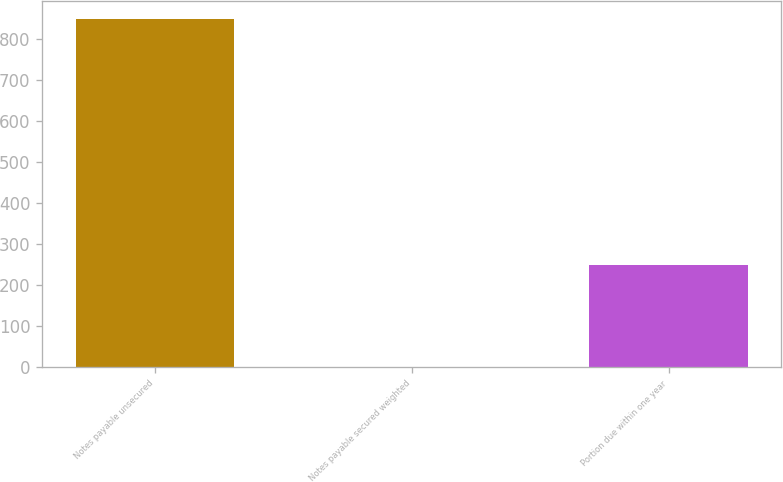<chart> <loc_0><loc_0><loc_500><loc_500><bar_chart><fcel>Notes payable unsecured<fcel>Notes payable secured weighted<fcel>Portion due within one year<nl><fcel>850<fcel>1<fcel>250<nl></chart> 